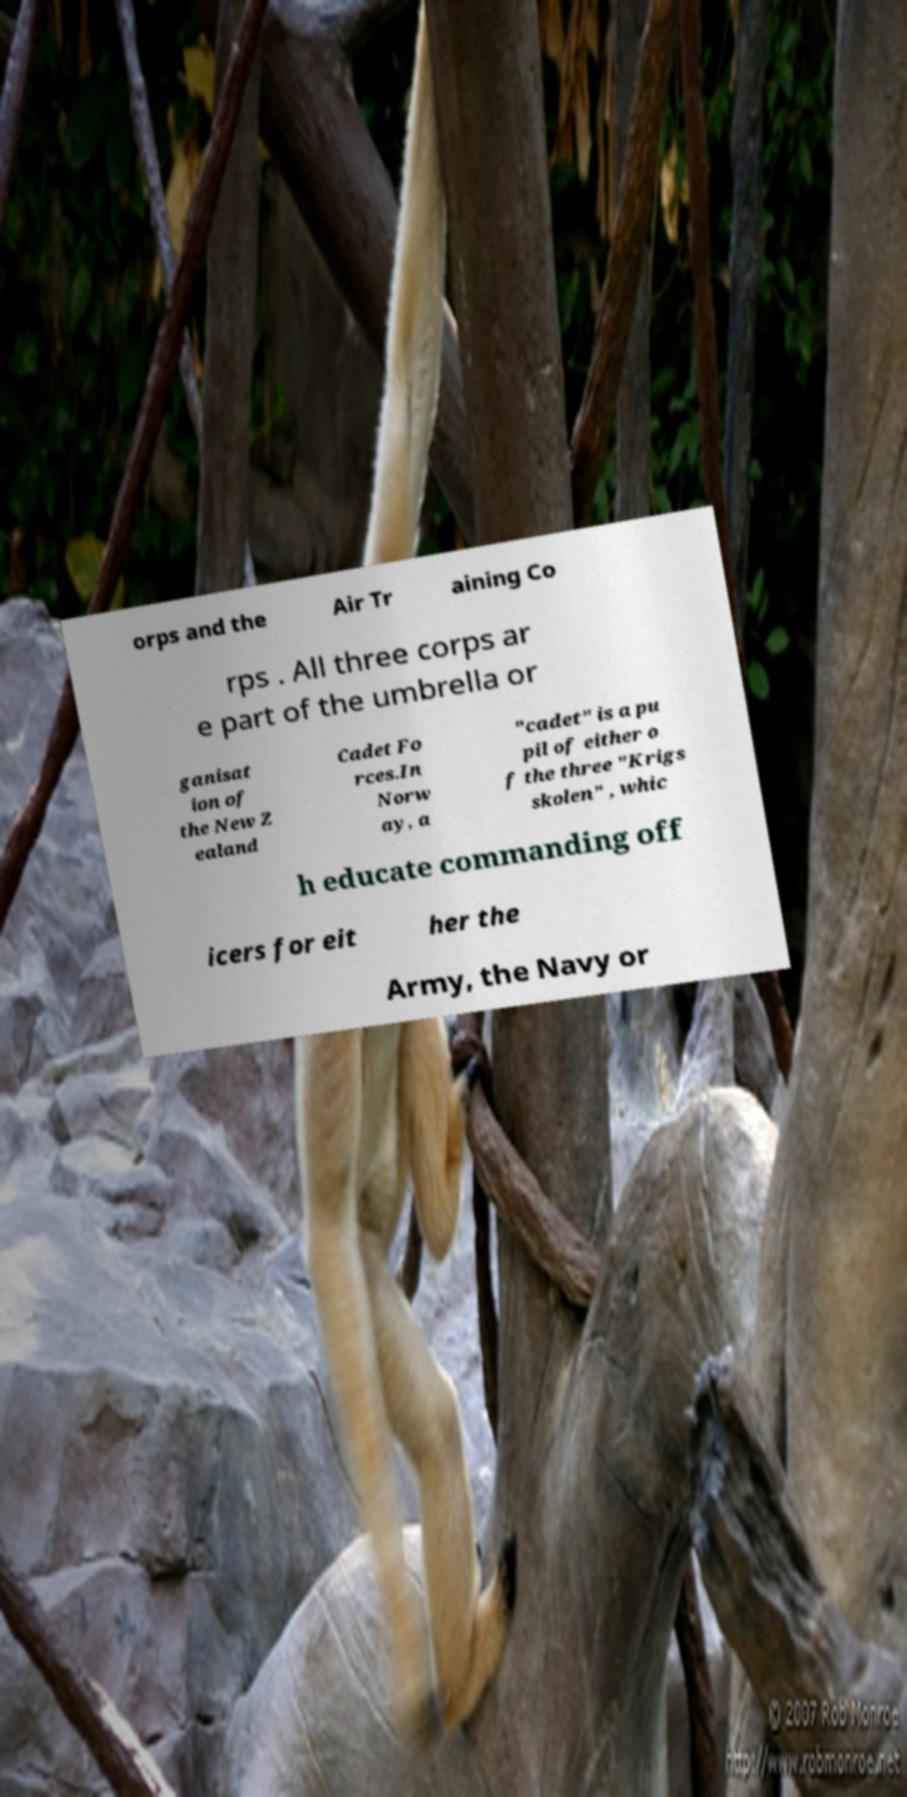What messages or text are displayed in this image? I need them in a readable, typed format. orps and the Air Tr aining Co rps . All three corps ar e part of the umbrella or ganisat ion of the New Z ealand Cadet Fo rces.In Norw ay, a "cadet" is a pu pil of either o f the three "Krigs skolen" , whic h educate commanding off icers for eit her the Army, the Navy or 